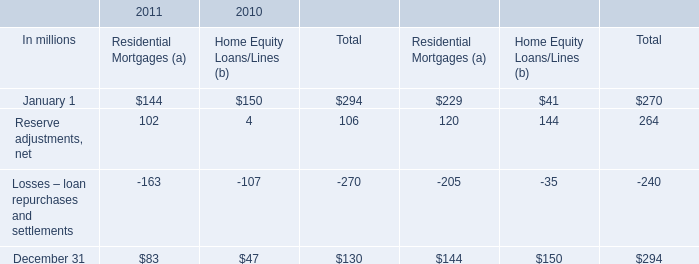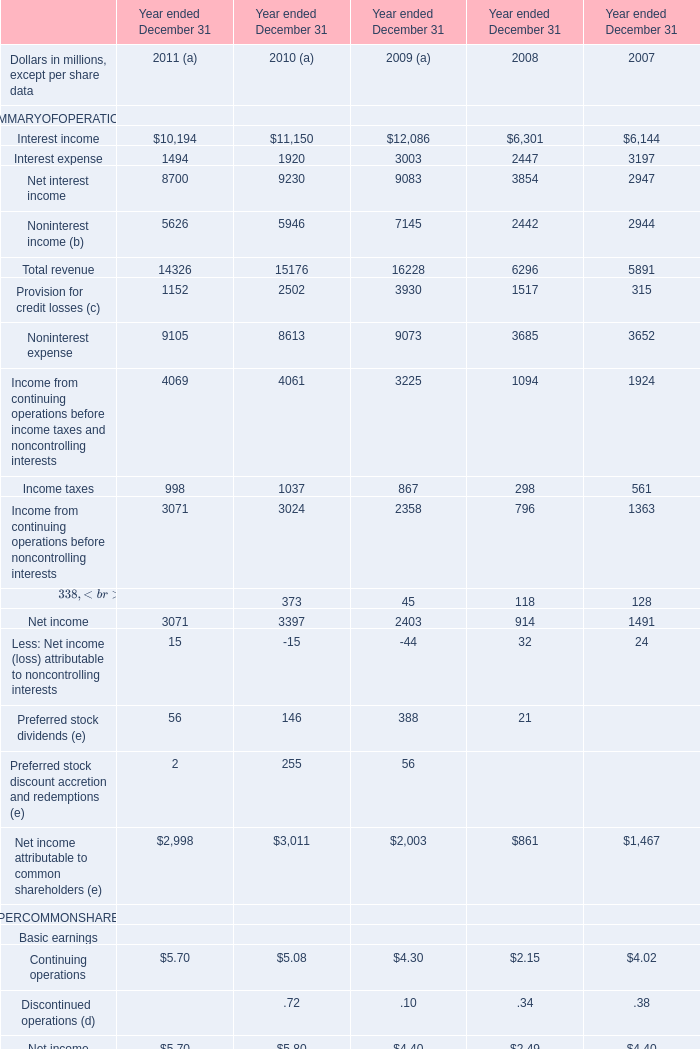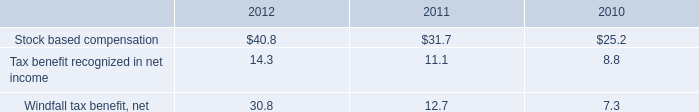In the year with the most Noninterest income (b), what is the growth rate of Noninterest income (b)? 
Computations: ((7145 - 2442) / 7145)
Answer: 0.65822. 